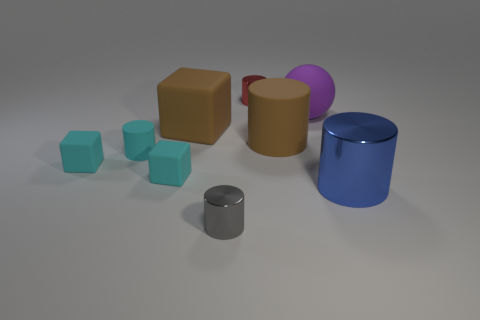Is the color of the large cube the same as the big rubber cylinder?
Make the answer very short. Yes. How many yellow objects are either big matte cylinders or rubber cylinders?
Give a very brief answer. 0. The large cube that is the same material as the big purple thing is what color?
Make the answer very short. Brown. There is a large matte cylinder; is it the same color as the big matte object left of the red shiny object?
Ensure brevity in your answer.  Yes. There is a small object that is both behind the large blue metal object and on the right side of the brown matte cube; what is its color?
Make the answer very short. Red. There is a big metallic thing; how many objects are behind it?
Provide a short and direct response. 7. How many things are small gray shiny cylinders or tiny cylinders in front of the large blue thing?
Keep it short and to the point. 1. Are there any blue metallic cylinders that are right of the tiny shiny cylinder that is behind the brown rubber cylinder?
Offer a very short reply. Yes. There is a rubber cylinder that is to the left of the gray cylinder; what is its color?
Provide a short and direct response. Cyan. Are there an equal number of tiny gray metal objects on the left side of the gray cylinder and gray cylinders?
Provide a short and direct response. No. 